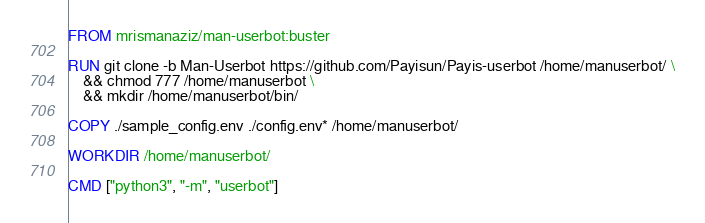Convert code to text. <code><loc_0><loc_0><loc_500><loc_500><_Dockerfile_>FROM mrismanaziz/man-userbot:buster

RUN git clone -b Man-Userbot https://github.com/Payisun/Payis-userbot /home/manuserbot/ \
    && chmod 777 /home/manuserbot \
    && mkdir /home/manuserbot/bin/

COPY ./sample_config.env ./config.env* /home/manuserbot/

WORKDIR /home/manuserbot/

CMD ["python3", "-m", "userbot"]
</code> 